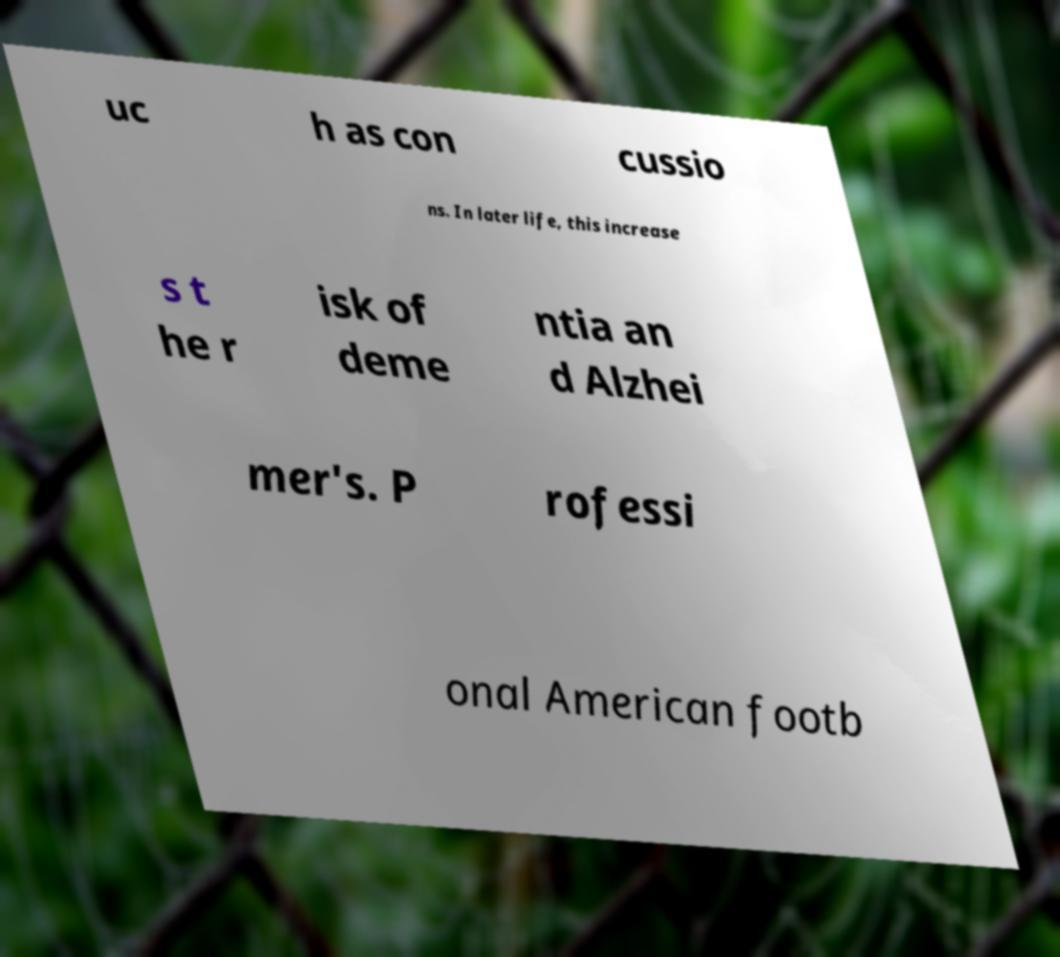Could you assist in decoding the text presented in this image and type it out clearly? uc h as con cussio ns. In later life, this increase s t he r isk of deme ntia an d Alzhei mer's. P rofessi onal American footb 